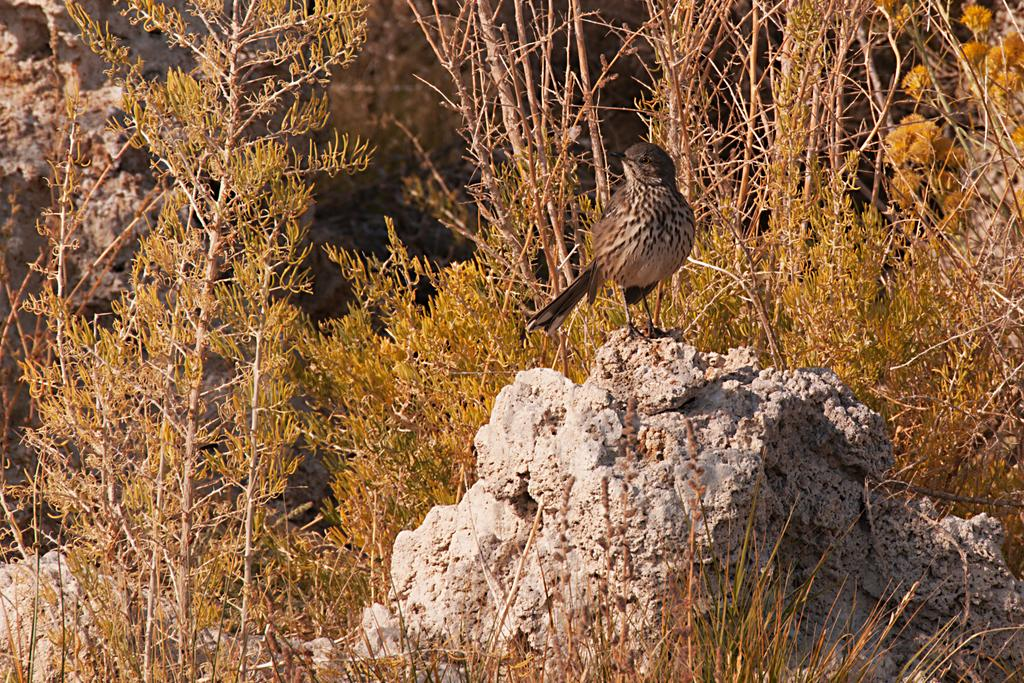What type of animal can be seen in the image? There is a bird in the image. Can you describe the bird's appearance? The bird is brown and cream in color. Where is the bird located in the image? The bird is on a rock. What else can be seen in the image besides the bird? There are plants in the image. How would you describe the background of the image? The background of the image is blurry. How many snails can be seen gripping the bird's fang in the image? There are no snails or fangs present in the image; it features of a bird are not described in the provided facts. 